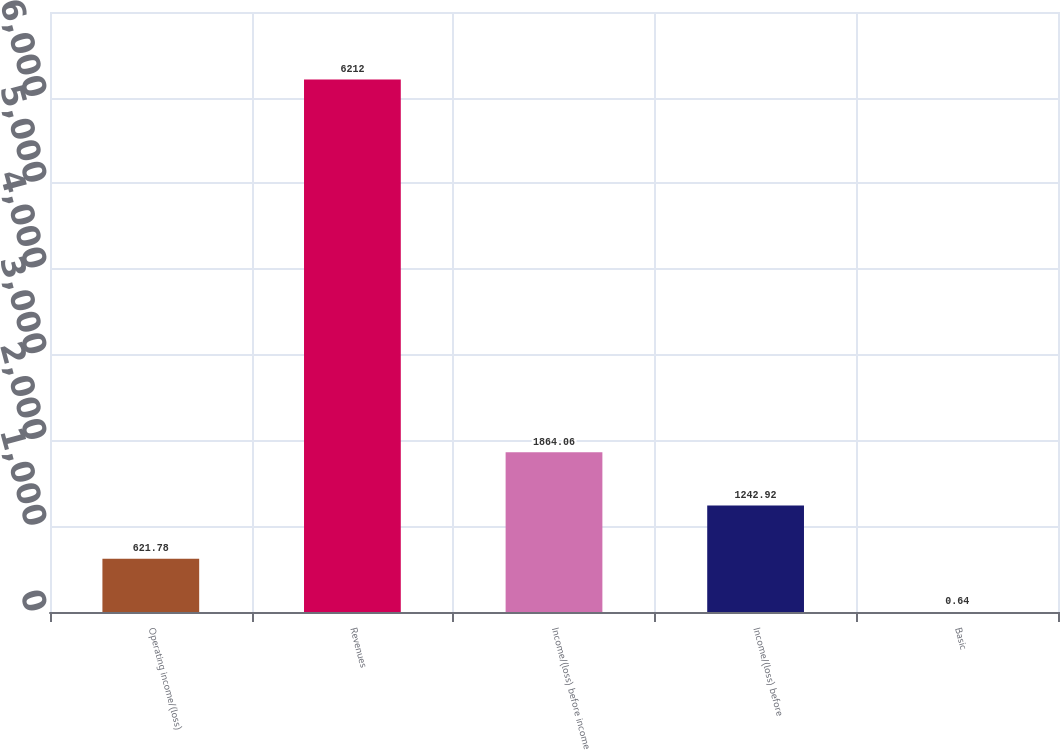Convert chart. <chart><loc_0><loc_0><loc_500><loc_500><bar_chart><fcel>Operating income/(loss)<fcel>Revenues<fcel>Income/(loss) before income<fcel>Income/(loss) before<fcel>Basic<nl><fcel>621.78<fcel>6212<fcel>1864.06<fcel>1242.92<fcel>0.64<nl></chart> 